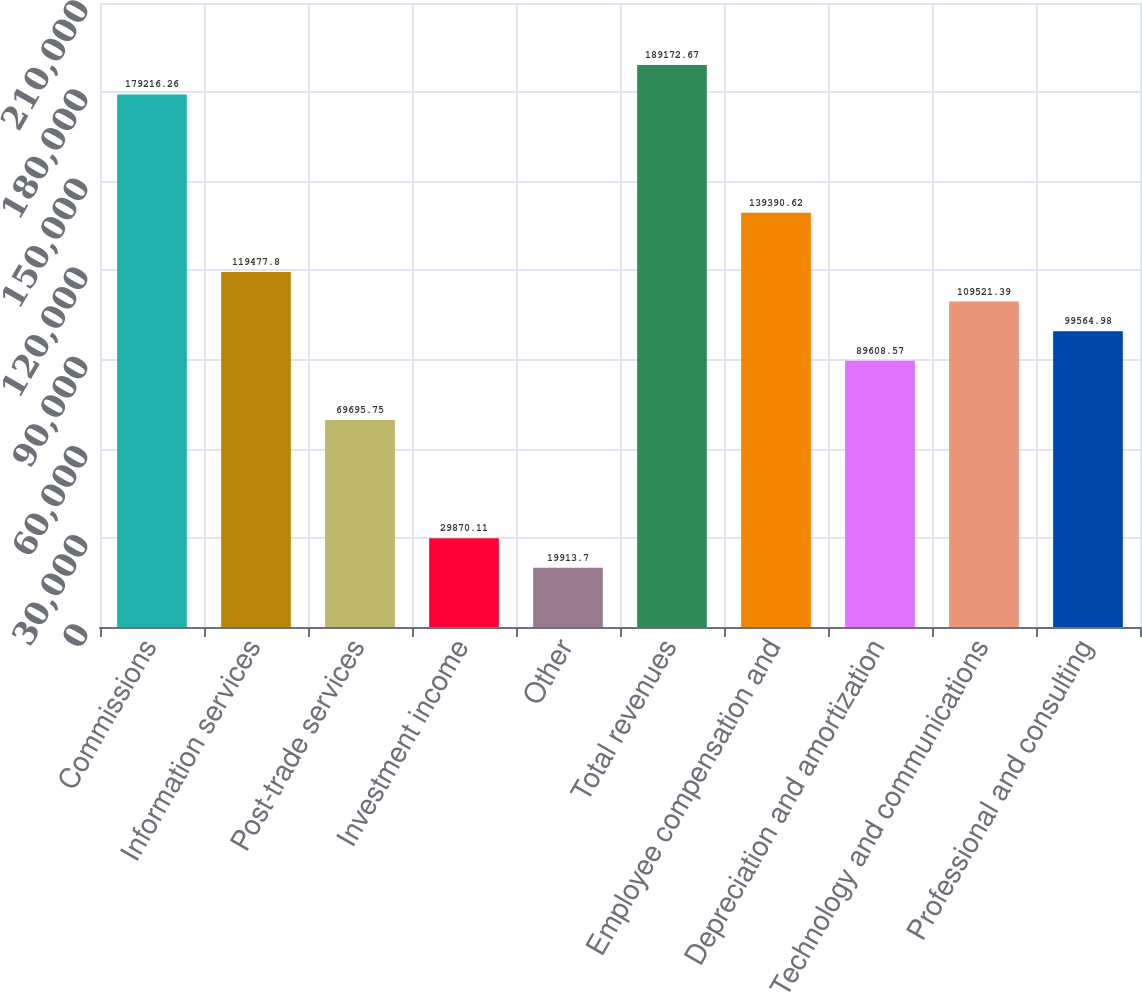Convert chart to OTSL. <chart><loc_0><loc_0><loc_500><loc_500><bar_chart><fcel>Commissions<fcel>Information services<fcel>Post-trade services<fcel>Investment income<fcel>Other<fcel>Total revenues<fcel>Employee compensation and<fcel>Depreciation and amortization<fcel>Technology and communications<fcel>Professional and consulting<nl><fcel>179216<fcel>119478<fcel>69695.8<fcel>29870.1<fcel>19913.7<fcel>189173<fcel>139391<fcel>89608.6<fcel>109521<fcel>99565<nl></chart> 